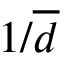Convert formula to latex. <formula><loc_0><loc_0><loc_500><loc_500>1 / \overline { d }</formula> 